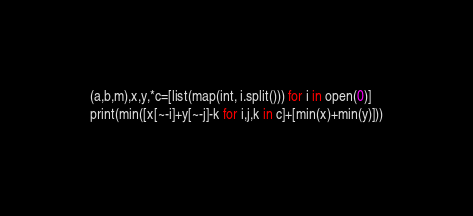<code> <loc_0><loc_0><loc_500><loc_500><_Python_>(a,b,m),x,y,*c=[list(map(int, i.split())) for i in open(0)]
print(min([x[~-i]+y[~-j]-k for i,j,k in c]+[min(x)+min(y)]))</code> 